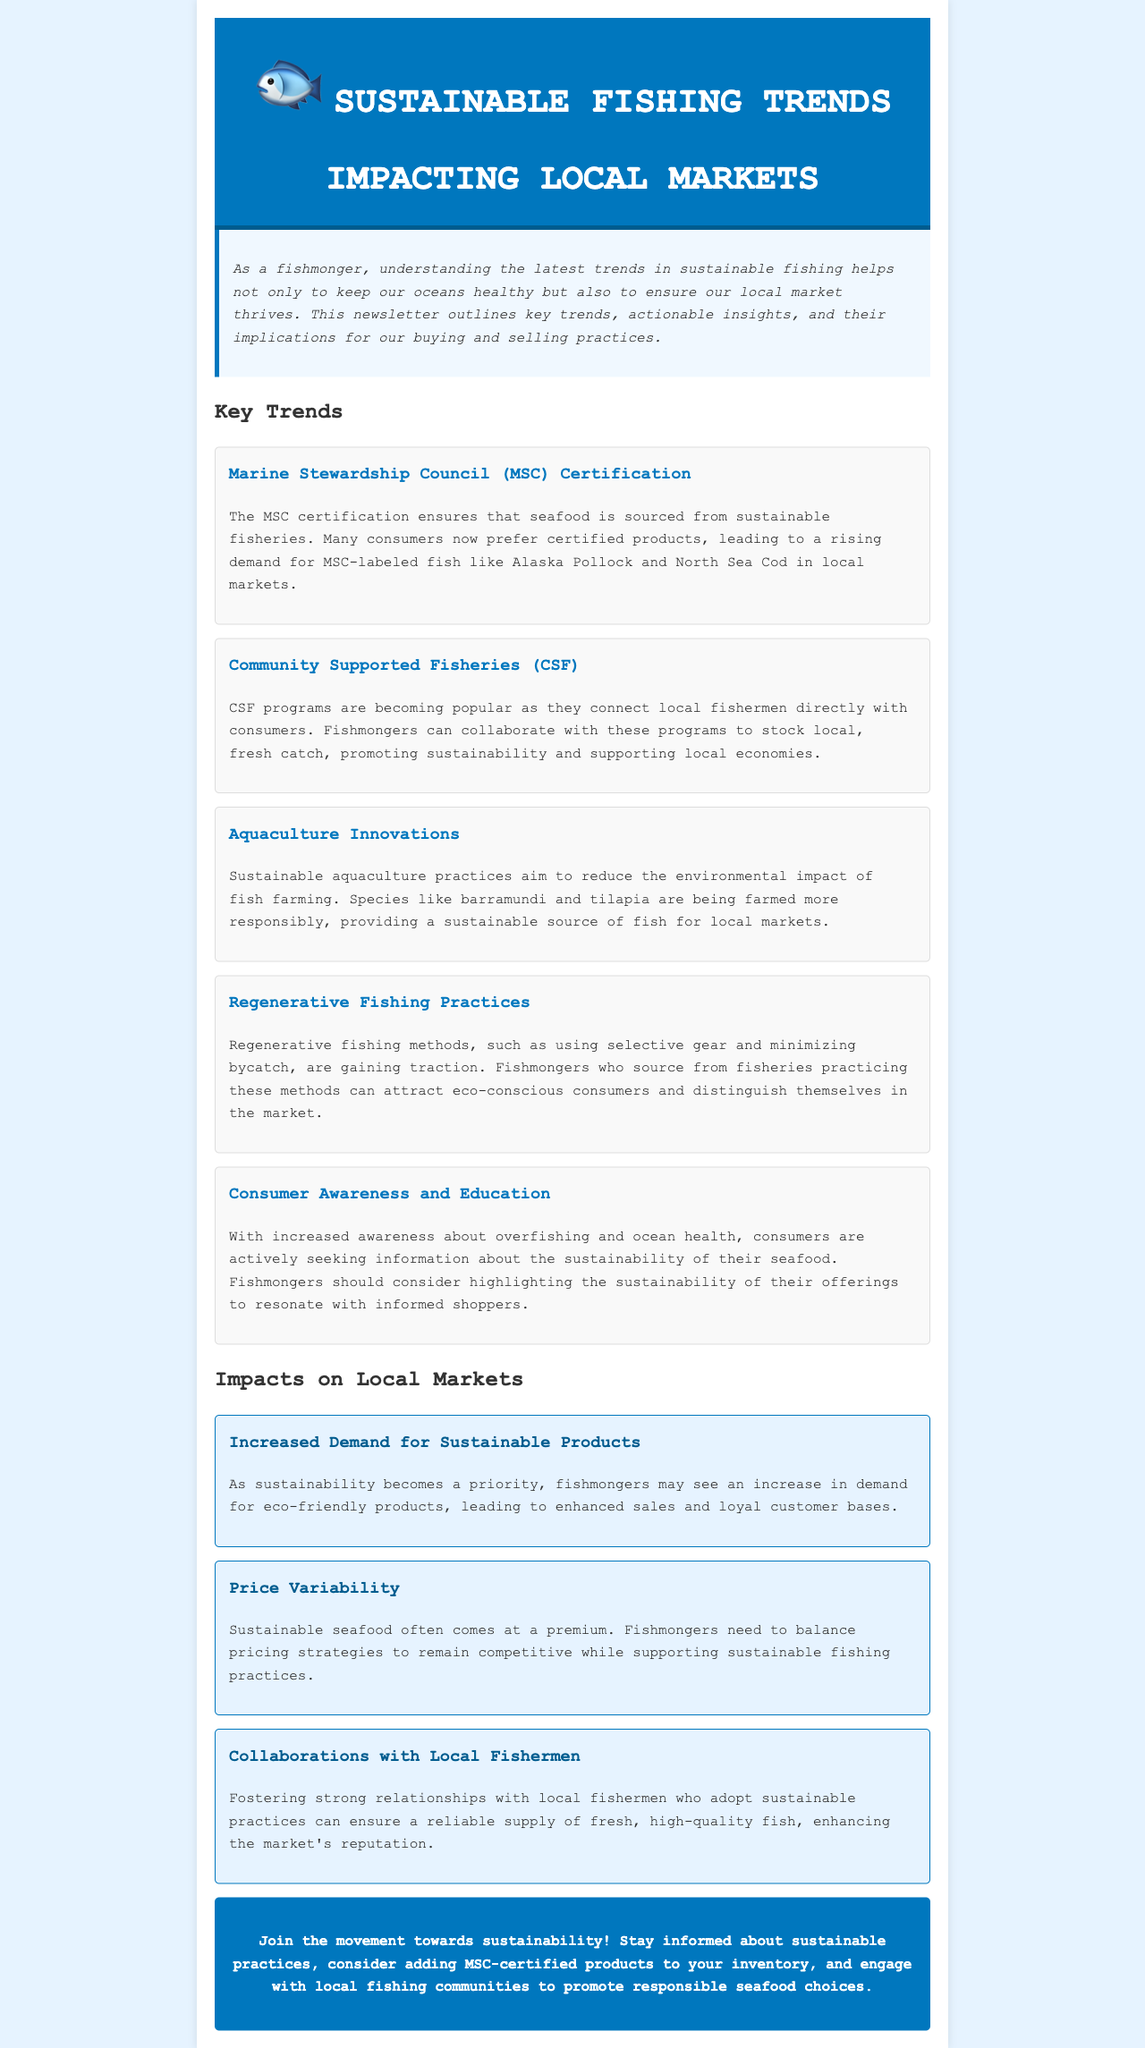What is the primary certification mentioned? The document specifically mentions the Marine Stewardship Council (MSC) certification, which is a key trend in sustainable fishing.
Answer: Marine Stewardship Council (MSC) Name one fish highlighted for MSC certification. The document lists Alaska Pollock and North Sea Cod as fish that are preferred due to MSC certification.
Answer: Alaska Pollock What are Community Supported Fisheries abbreviated as? The document indicates that Community Supported Fisheries is abbreviated as CSF.
Answer: CSF Which species are mentioned as being farmed sustainably in aquaculture? The document references barramundi and tilapia as species being farmed more responsibly.
Answer: Barramundi and tilapia What is a consequence of increased demand for sustainable products? The document states that increased demand may lead to enhanced sales and loyal customer bases for fishmongers.
Answer: Enhanced sales How do sustainable seafood prices typically compare? The document notes that sustainable seafood often comes at a premium, implying higher prices compared to non-sustainable options.
Answer: Premium What method is gaining traction for reducing bycatch? The document mentions that regenerative fishing practices, which include using selective gear, are gaining traction for minimizing bycatch.
Answer: Regenerative fishing practices What should fishmongers highlight to resonate with informed shoppers? The document advises fishmongers to emphasize the sustainability of their offerings to connect with eco-conscious consumers.
Answer: Sustainability of offerings How can fishmongers enhance their market reputation? The document states that fostering strong relationships with local fishermen practicing sustainable methods can enhance the market's reputation.
Answer: Collaborations with local fishermen 